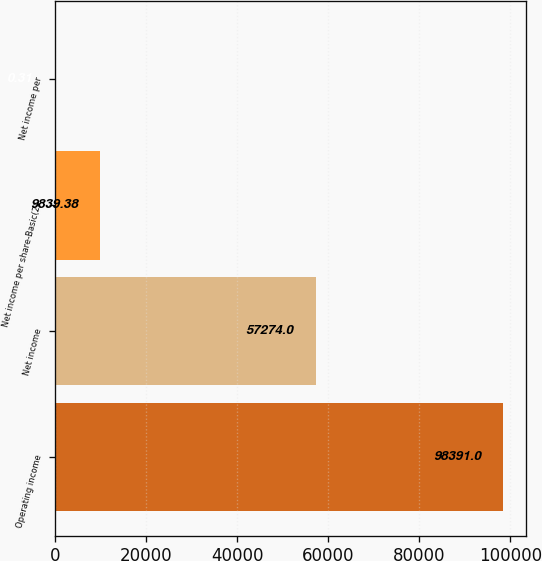<chart> <loc_0><loc_0><loc_500><loc_500><bar_chart><fcel>Operating income<fcel>Net income<fcel>Net income per share-Basic(2)<fcel>Net income per<nl><fcel>98391<fcel>57274<fcel>9839.38<fcel>0.31<nl></chart> 